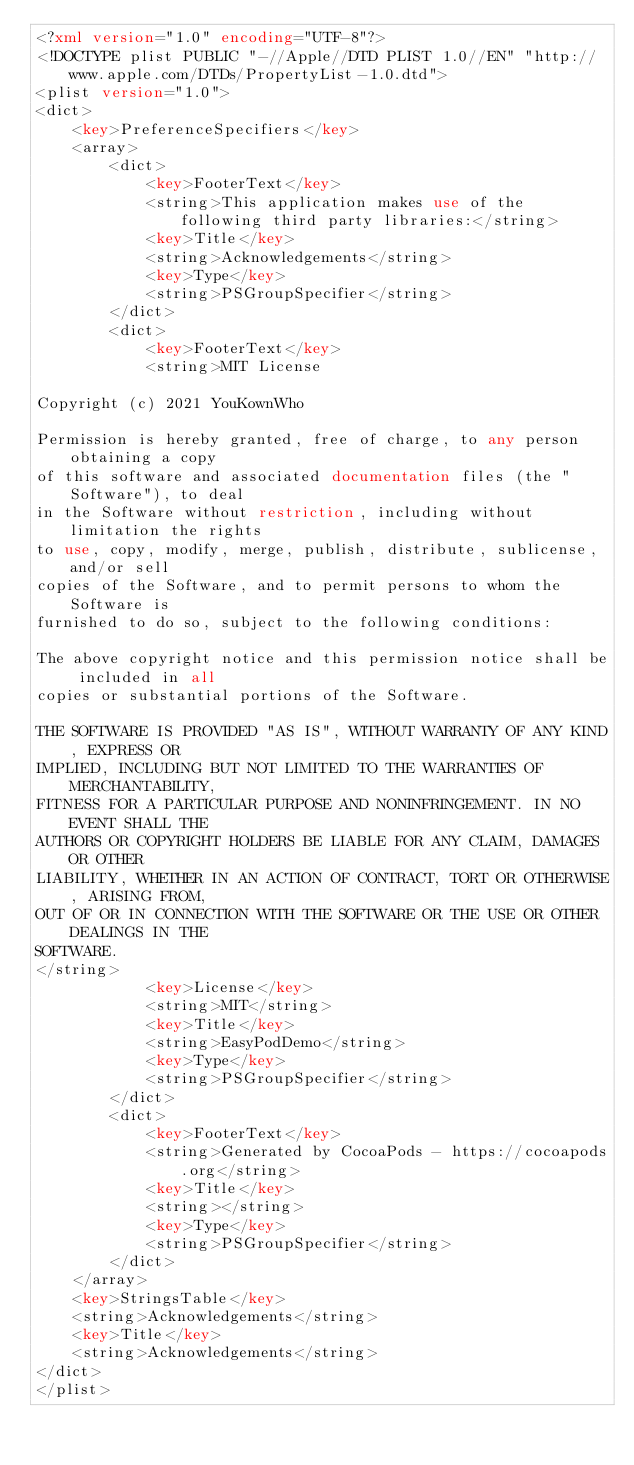Convert code to text. <code><loc_0><loc_0><loc_500><loc_500><_XML_><?xml version="1.0" encoding="UTF-8"?>
<!DOCTYPE plist PUBLIC "-//Apple//DTD PLIST 1.0//EN" "http://www.apple.com/DTDs/PropertyList-1.0.dtd">
<plist version="1.0">
<dict>
	<key>PreferenceSpecifiers</key>
	<array>
		<dict>
			<key>FooterText</key>
			<string>This application makes use of the following third party libraries:</string>
			<key>Title</key>
			<string>Acknowledgements</string>
			<key>Type</key>
			<string>PSGroupSpecifier</string>
		</dict>
		<dict>
			<key>FooterText</key>
			<string>MIT License

Copyright (c) 2021 YouKownWho

Permission is hereby granted, free of charge, to any person obtaining a copy
of this software and associated documentation files (the "Software"), to deal
in the Software without restriction, including without limitation the rights
to use, copy, modify, merge, publish, distribute, sublicense, and/or sell
copies of the Software, and to permit persons to whom the Software is
furnished to do so, subject to the following conditions:

The above copyright notice and this permission notice shall be included in all
copies or substantial portions of the Software.

THE SOFTWARE IS PROVIDED "AS IS", WITHOUT WARRANTY OF ANY KIND, EXPRESS OR
IMPLIED, INCLUDING BUT NOT LIMITED TO THE WARRANTIES OF MERCHANTABILITY,
FITNESS FOR A PARTICULAR PURPOSE AND NONINFRINGEMENT. IN NO EVENT SHALL THE
AUTHORS OR COPYRIGHT HOLDERS BE LIABLE FOR ANY CLAIM, DAMAGES OR OTHER
LIABILITY, WHETHER IN AN ACTION OF CONTRACT, TORT OR OTHERWISE, ARISING FROM,
OUT OF OR IN CONNECTION WITH THE SOFTWARE OR THE USE OR OTHER DEALINGS IN THE
SOFTWARE.
</string>
			<key>License</key>
			<string>MIT</string>
			<key>Title</key>
			<string>EasyPodDemo</string>
			<key>Type</key>
			<string>PSGroupSpecifier</string>
		</dict>
		<dict>
			<key>FooterText</key>
			<string>Generated by CocoaPods - https://cocoapods.org</string>
			<key>Title</key>
			<string></string>
			<key>Type</key>
			<string>PSGroupSpecifier</string>
		</dict>
	</array>
	<key>StringsTable</key>
	<string>Acknowledgements</string>
	<key>Title</key>
	<string>Acknowledgements</string>
</dict>
</plist>
</code> 